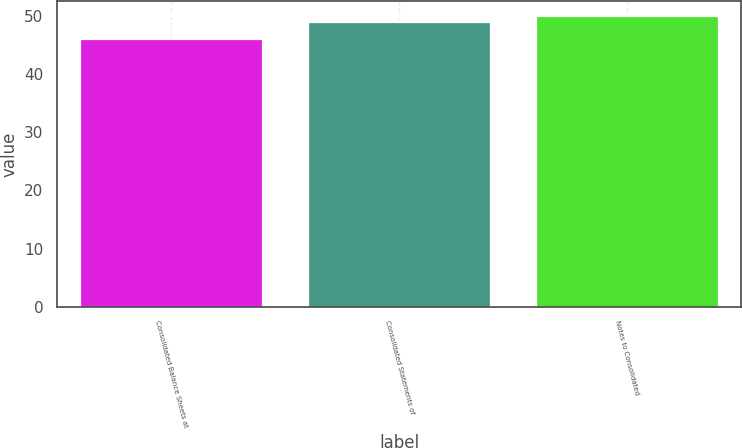Convert chart to OTSL. <chart><loc_0><loc_0><loc_500><loc_500><bar_chart><fcel>Consolidated Balance Sheets at<fcel>Consolidated Statements of<fcel>Notes to Consolidated<nl><fcel>46<fcel>49<fcel>50<nl></chart> 